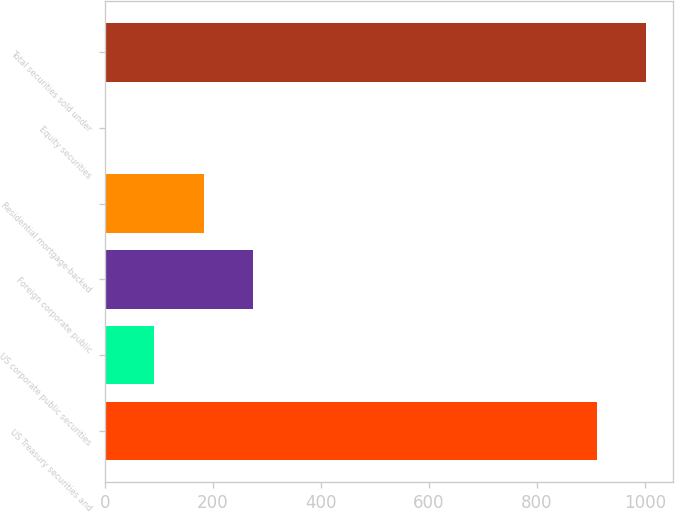Convert chart. <chart><loc_0><loc_0><loc_500><loc_500><bar_chart><fcel>US Treasury securities and<fcel>US corporate public securities<fcel>Foreign corporate public<fcel>Residential mortgage-backed<fcel>Equity securities<fcel>Total securities sold under<nl><fcel>911<fcel>91.86<fcel>274.12<fcel>182.99<fcel>0.73<fcel>1002.13<nl></chart> 